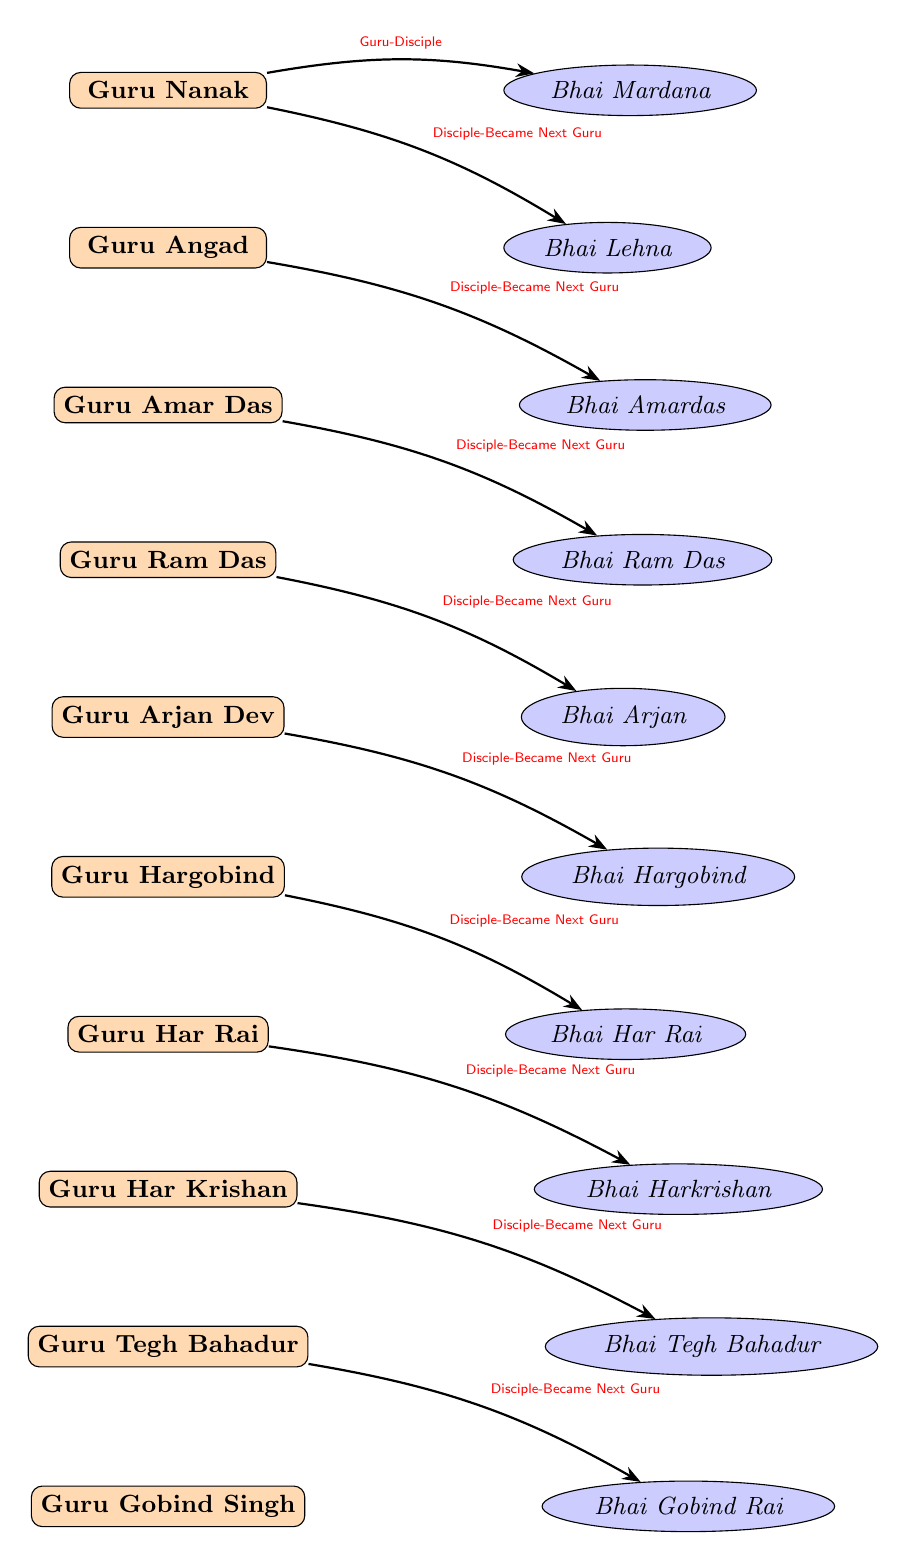What is the title of Guru Nanak? The diagram indicates that Guru Nanak is labeled as the "First Sikh Guru," which describes his position within the hierarchy of Sikh Gurus.
Answer: First Sikh Guru How many Sikh Gurus are mentioned in the diagram? By counting the number of nodes labeled as Gurus in the diagram, we find there are ten Sikh Gurus listed.
Answer: 10 Who is the key disciple of Guru Hargobind? The diagram shows an arrow labeled "Disciple-Became Next Guru" leading from Guru Hargobind to Bhai Hargobind, indicating that he is the key disciple of Guru Hargobind.
Answer: Bhai Hargobind What relationship exists between Guru Amar Das and Bhai Ram Das? The diagram illustrates that Guru Amar Das has an edge labeled "Disciple-Became Next Guru" pointing to Bhai Ram Das, indicating that he is the disciple who succeeded him.
Answer: Disciple-Became Next Guru Which Guru is succeeded by Guru Ram Das? Looking at the edges, we see that Guru Ram Das follows the line from Guru Amar Das who was his predecessor, so we conclude that Guru Amar Das is the one succeeded by Guru Ram Das.
Answer: Guru Amar Das Which Guru is directly connected to Bhai Tegh Bahadur? The edge labeled "Disciple-Became Next Guru" from Guru Har Krishan points to Bhai Tegh Bahadur, indicating that he is the disciple directly connected to Guru Har Krishan.
Answer: Guru Har Krishan How many relationships are indicated in the diagram? The diagram specifies ten edges that create relationships between the nodes, so we can count the total relationships displayed as edges.
Answer: 10 Which Sikh Guru directly follows Guru Angad? Analyzing the hierarchy, we can see that Guru Amar Das is the successor of Guru Angad, indicated by the edge labeled "Disciple-Became Next Guru."
Answer: Guru Amar Das Who is the tenth Sikh Guru? The final node labeled Guru Gobind Singh indicates that he is recognized as the tenth Sikh Guru in the hierarchy laid out in the diagram.
Answer: Guru Gobind Singh 